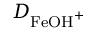<formula> <loc_0><loc_0><loc_500><loc_500>D _ { F e O H ^ { + } }</formula> 